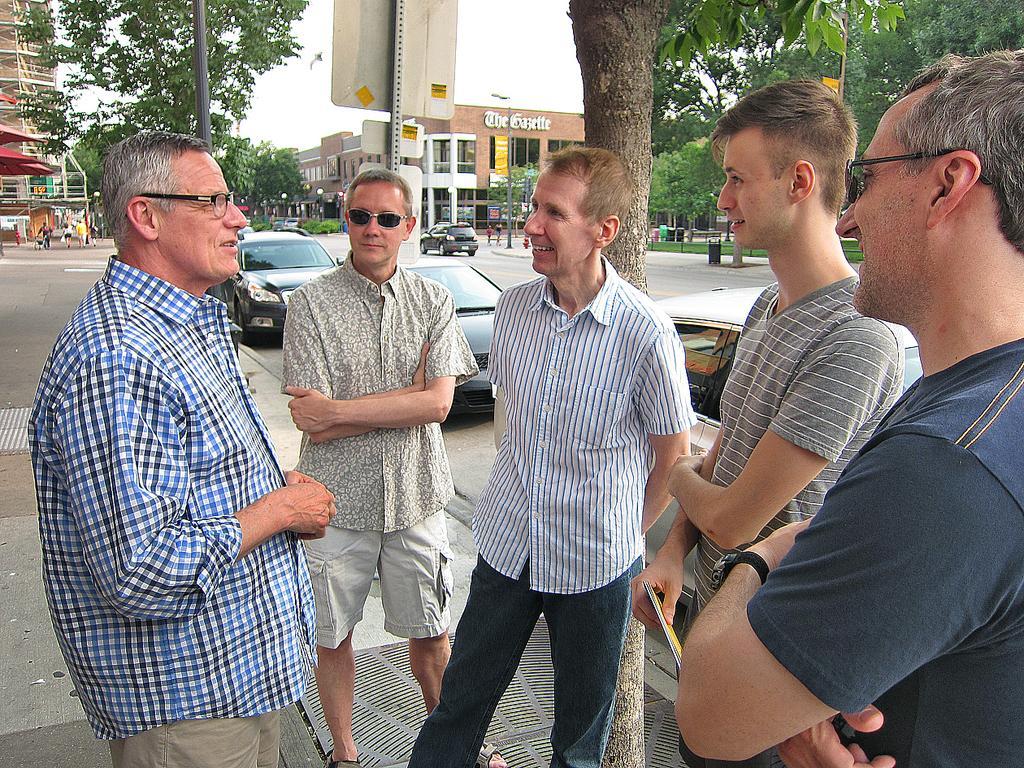How would you summarize this image in a sentence or two? In this image there are people standing on a road, in the background there are cars trees, buildings and the sky. 